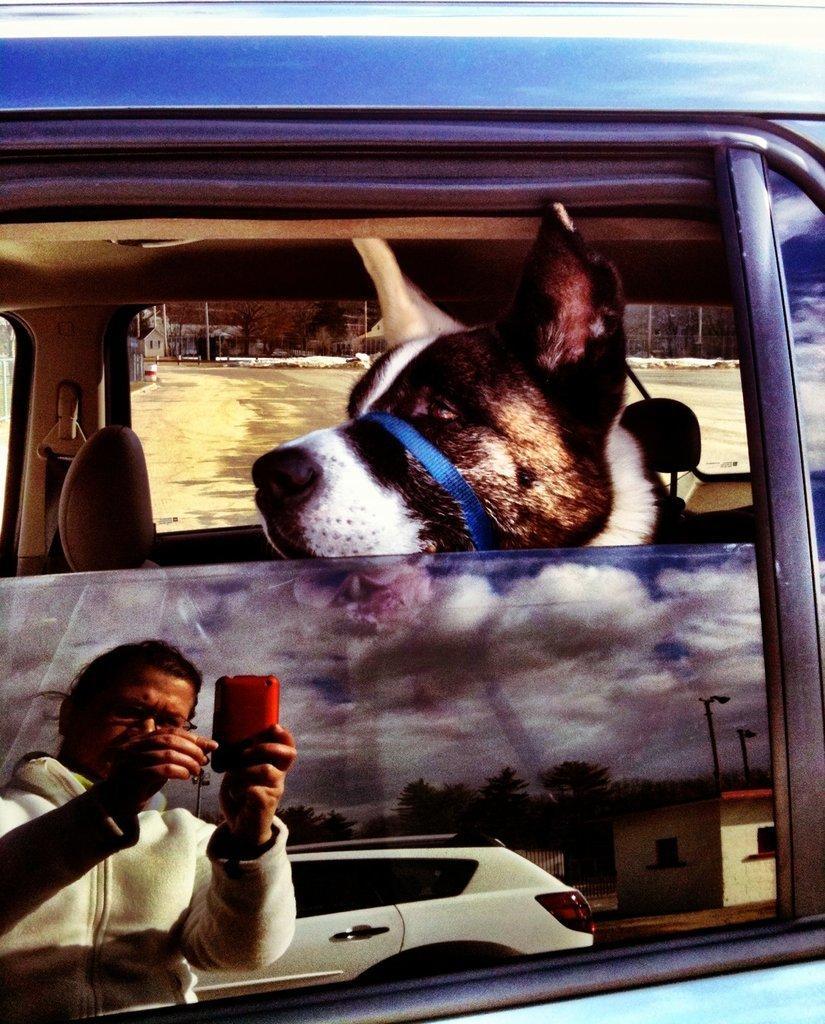Describe this image in one or two sentences. In the car there is a dog. In the window we can see a man with white jacket is taking a picture with his mobile. Beside him there is a white color car. In the background there is a house. 